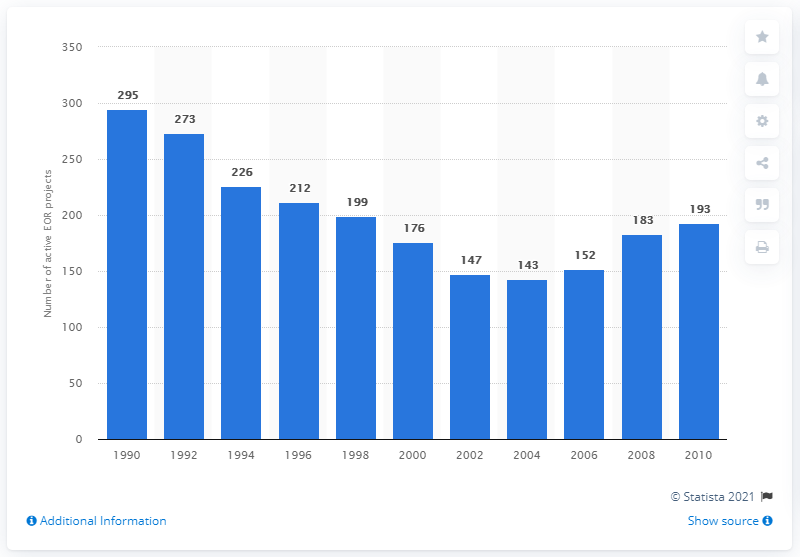List a handful of essential elements in this visual. In 1990, there were 295 Enhanced Oil Recovery (EOR) projects that contributed to crude oil production in the United States. 